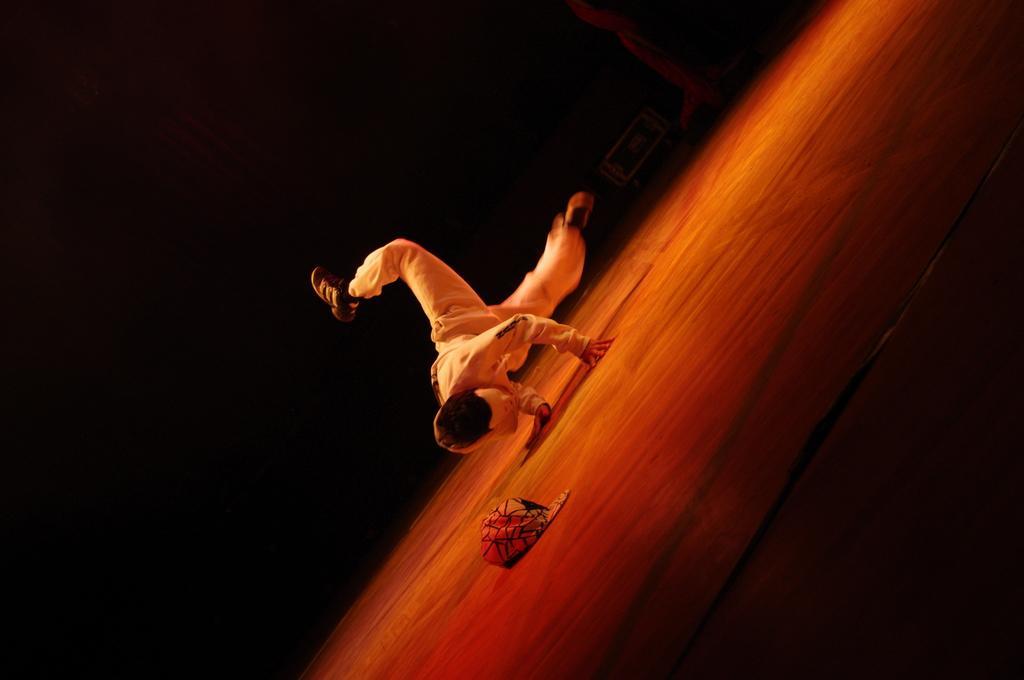Please provide a concise description of this image. In this image I can see a person and a cap on the floor. I can also see the background is black in color. 